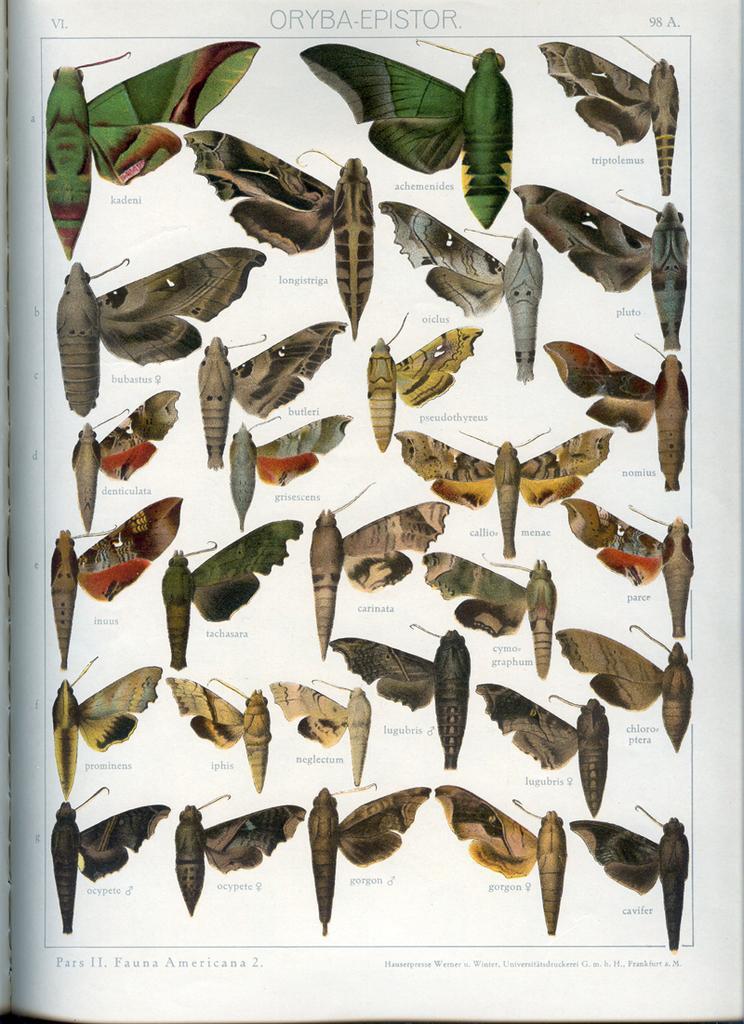Can you describe this image briefly? This picture is a paper. In this image we can see insects, text. 